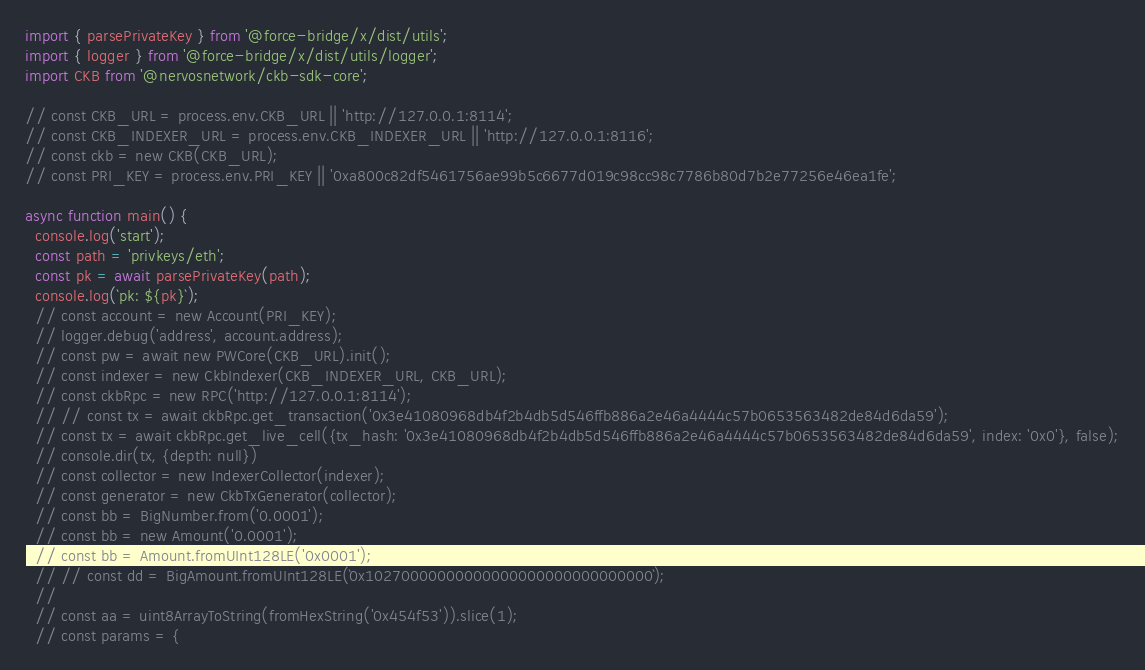<code> <loc_0><loc_0><loc_500><loc_500><_TypeScript_>import { parsePrivateKey } from '@force-bridge/x/dist/utils';
import { logger } from '@force-bridge/x/dist/utils/logger';
import CKB from '@nervosnetwork/ckb-sdk-core';

// const CKB_URL = process.env.CKB_URL || 'http://127.0.0.1:8114';
// const CKB_INDEXER_URL = process.env.CKB_INDEXER_URL || 'http://127.0.0.1:8116';
// const ckb = new CKB(CKB_URL);
// const PRI_KEY = process.env.PRI_KEY || '0xa800c82df5461756ae99b5c6677d019c98cc98c7786b80d7b2e77256e46ea1fe';

async function main() {
  console.log('start');
  const path = 'privkeys/eth';
  const pk = await parsePrivateKey(path);
  console.log(`pk: ${pk}`);
  // const account = new Account(PRI_KEY);
  // logger.debug('address', account.address);
  // const pw = await new PWCore(CKB_URL).init();
  // const indexer = new CkbIndexer(CKB_INDEXER_URL, CKB_URL);
  // const ckbRpc = new RPC('http://127.0.0.1:8114');
  // // const tx = await ckbRpc.get_transaction('0x3e41080968db4f2b4db5d546ffb886a2e46a4444c57b0653563482de84d6da59');
  // const tx = await ckbRpc.get_live_cell({tx_hash: '0x3e41080968db4f2b4db5d546ffb886a2e46a4444c57b0653563482de84d6da59', index: '0x0'}, false);
  // console.dir(tx, {depth: null})
  // const collector = new IndexerCollector(indexer);
  // const generator = new CkbTxGenerator(collector);
  // const bb = BigNumber.from('0.0001');
  // const bb = new Amount('0.0001');
  // const bb = Amount.fromUInt128LE('0x0001');
  // // const dd = BigAmount.fromUInt128LE(`0x10270000000000000000000000000000`);
  //
  // const aa = uint8ArrayToString(fromHexString('0x454f53')).slice(1);
  // const params = {</code> 